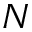<formula> <loc_0><loc_0><loc_500><loc_500>N</formula> 